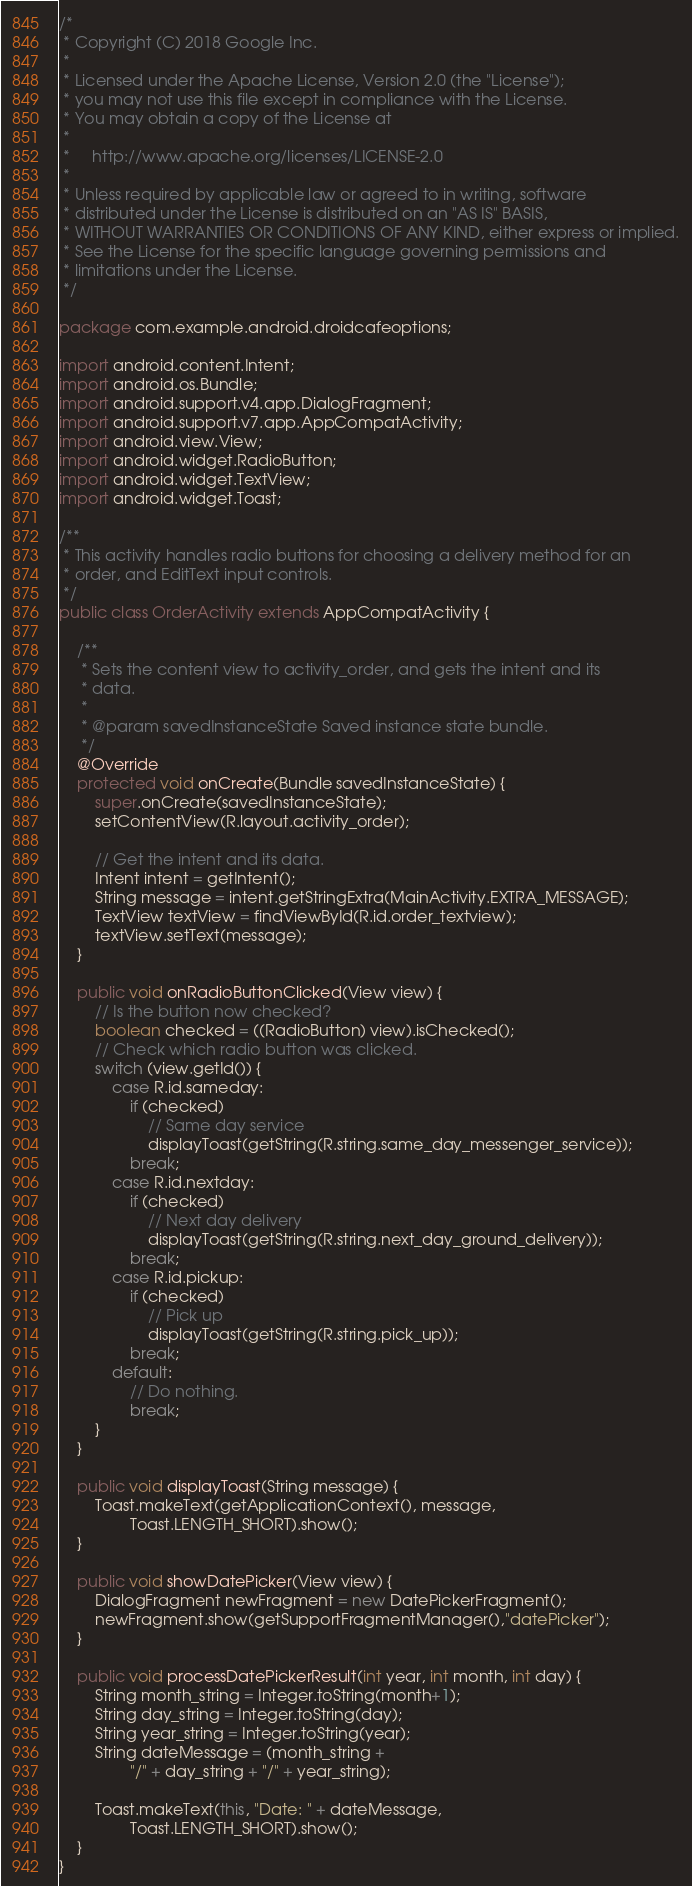Convert code to text. <code><loc_0><loc_0><loc_500><loc_500><_Java_>/*
 * Copyright (C) 2018 Google Inc.
 *
 * Licensed under the Apache License, Version 2.0 (the "License");
 * you may not use this file except in compliance with the License.
 * You may obtain a copy of the License at
 *
 *     http://www.apache.org/licenses/LICENSE-2.0
 *
 * Unless required by applicable law or agreed to in writing, software
 * distributed under the License is distributed on an "AS IS" BASIS,
 * WITHOUT WARRANTIES OR CONDITIONS OF ANY KIND, either express or implied.
 * See the License for the specific language governing permissions and
 * limitations under the License.
 */

package com.example.android.droidcafeoptions;

import android.content.Intent;
import android.os.Bundle;
import android.support.v4.app.DialogFragment;
import android.support.v7.app.AppCompatActivity;
import android.view.View;
import android.widget.RadioButton;
import android.widget.TextView;
import android.widget.Toast;

/**
 * This activity handles radio buttons for choosing a delivery method for an
 * order, and EditText input controls.
 */
public class OrderActivity extends AppCompatActivity {

    /**
     * Sets the content view to activity_order, and gets the intent and its
     * data.
     *
     * @param savedInstanceState Saved instance state bundle.
     */
    @Override
    protected void onCreate(Bundle savedInstanceState) {
        super.onCreate(savedInstanceState);
        setContentView(R.layout.activity_order);

        // Get the intent and its data.
        Intent intent = getIntent();
        String message = intent.getStringExtra(MainActivity.EXTRA_MESSAGE);
        TextView textView = findViewById(R.id.order_textview);
        textView.setText(message);
    }

    public void onRadioButtonClicked(View view) {
        // Is the button now checked?
        boolean checked = ((RadioButton) view).isChecked();
        // Check which radio button was clicked.
        switch (view.getId()) {
            case R.id.sameday:
                if (checked)
                    // Same day service
                    displayToast(getString(R.string.same_day_messenger_service));
                break;
            case R.id.nextday:
                if (checked)
                    // Next day delivery
                    displayToast(getString(R.string.next_day_ground_delivery));
                break;
            case R.id.pickup:
                if (checked)
                    // Pick up
                    displayToast(getString(R.string.pick_up));
                break;
            default:
                // Do nothing.
                break;
        }
    }

    public void displayToast(String message) {
        Toast.makeText(getApplicationContext(), message,
                Toast.LENGTH_SHORT).show();
    }

    public void showDatePicker(View view) {
        DialogFragment newFragment = new DatePickerFragment();
        newFragment.show(getSupportFragmentManager(),"datePicker");
    }

    public void processDatePickerResult(int year, int month, int day) {
        String month_string = Integer.toString(month+1);
        String day_string = Integer.toString(day);
        String year_string = Integer.toString(year);
        String dateMessage = (month_string +
                "/" + day_string + "/" + year_string);

        Toast.makeText(this, "Date: " + dateMessage,
                Toast.LENGTH_SHORT).show();
    }
}
</code> 